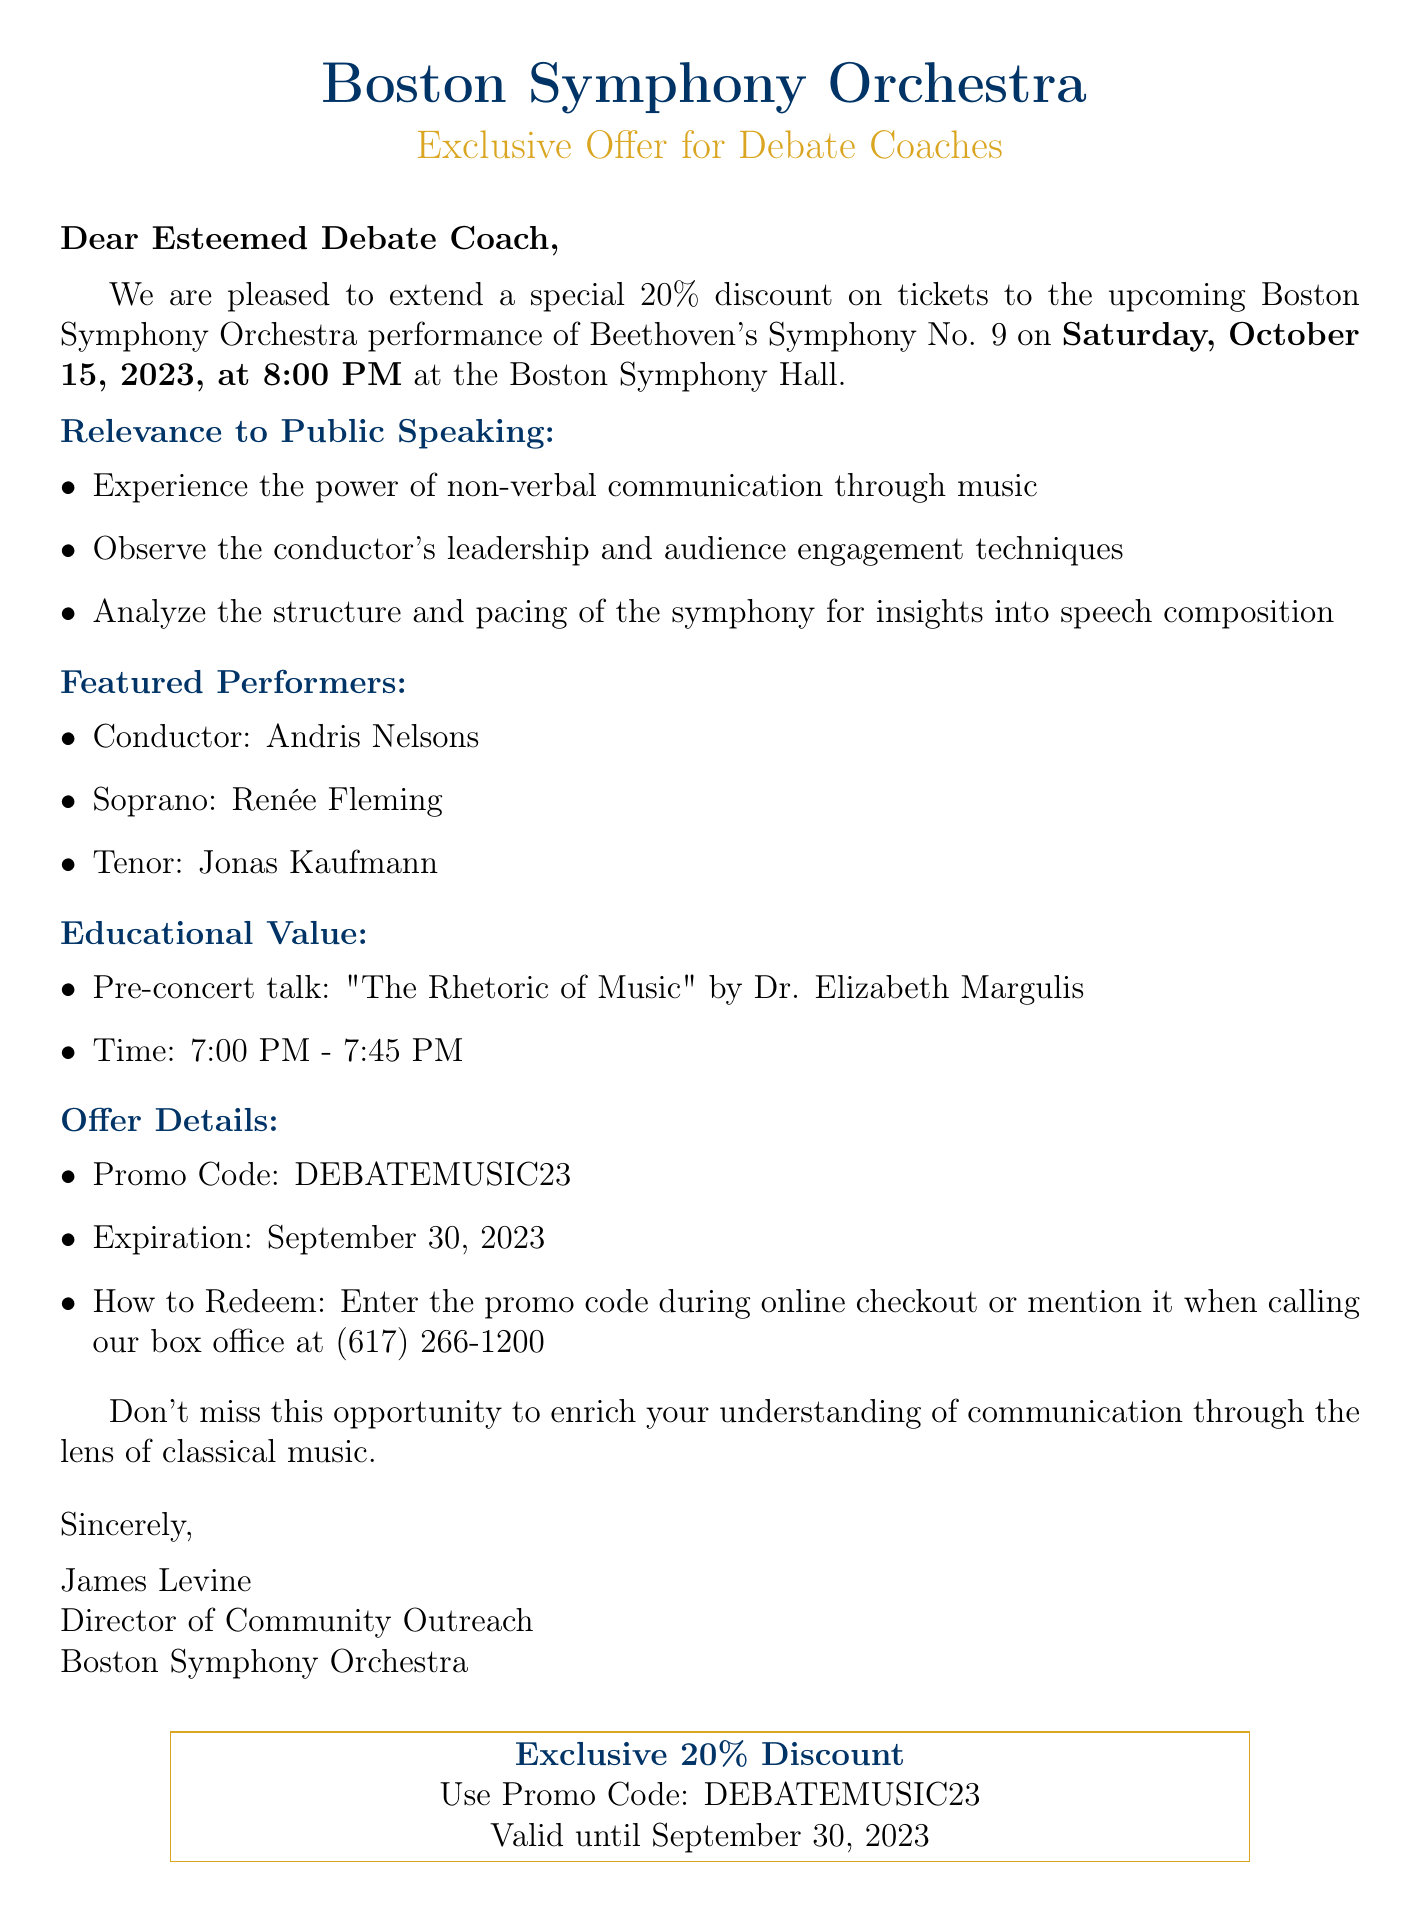What is the date of the performance? The performance is scheduled on Saturday, October 15, 2023.
Answer: Saturday, October 15, 2023 Who is the conductor of the orchestra? The document mentions Andris Nelsons as the conductor.
Answer: Andris Nelsons What is the discount percentage offered on tickets? The document states a special 20% discount on tickets.
Answer: 20% What is the name of the workshop speaker? The pre-concert talk is given by Dr. Elizabeth Margulis.
Answer: Dr. Elizabeth Margulis What time does the pre-concert talk start? The pre-concert talk starts at 7:00 PM.
Answer: 7:00 PM How do you redeem the offer? The promo code can be entered during online checkout or mentioned when calling the box office.
Answer: Enter during online checkout or mention when calling What is the promo code for the ticket discount? The promo code specified in the document is DEBATEMUSIC23.
Answer: DEBATEMUSIC23 What type of music piece is being performed? The performance features Beethoven's Symphony No. 9.
Answer: Beethoven's Symphony No. 9 